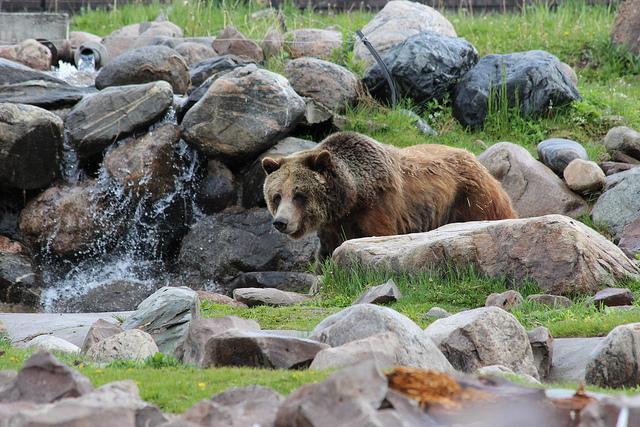How many bears are there?
Give a very brief answer. 1. How many men are wearing a tie?
Give a very brief answer. 0. 